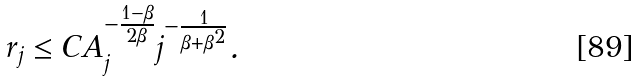<formula> <loc_0><loc_0><loc_500><loc_500>r _ { j } \leq C A _ { j } ^ { - \frac { 1 - \beta } { 2 \beta } } j ^ { - \frac { 1 } { \beta + \beta ^ { 2 } } } .</formula> 